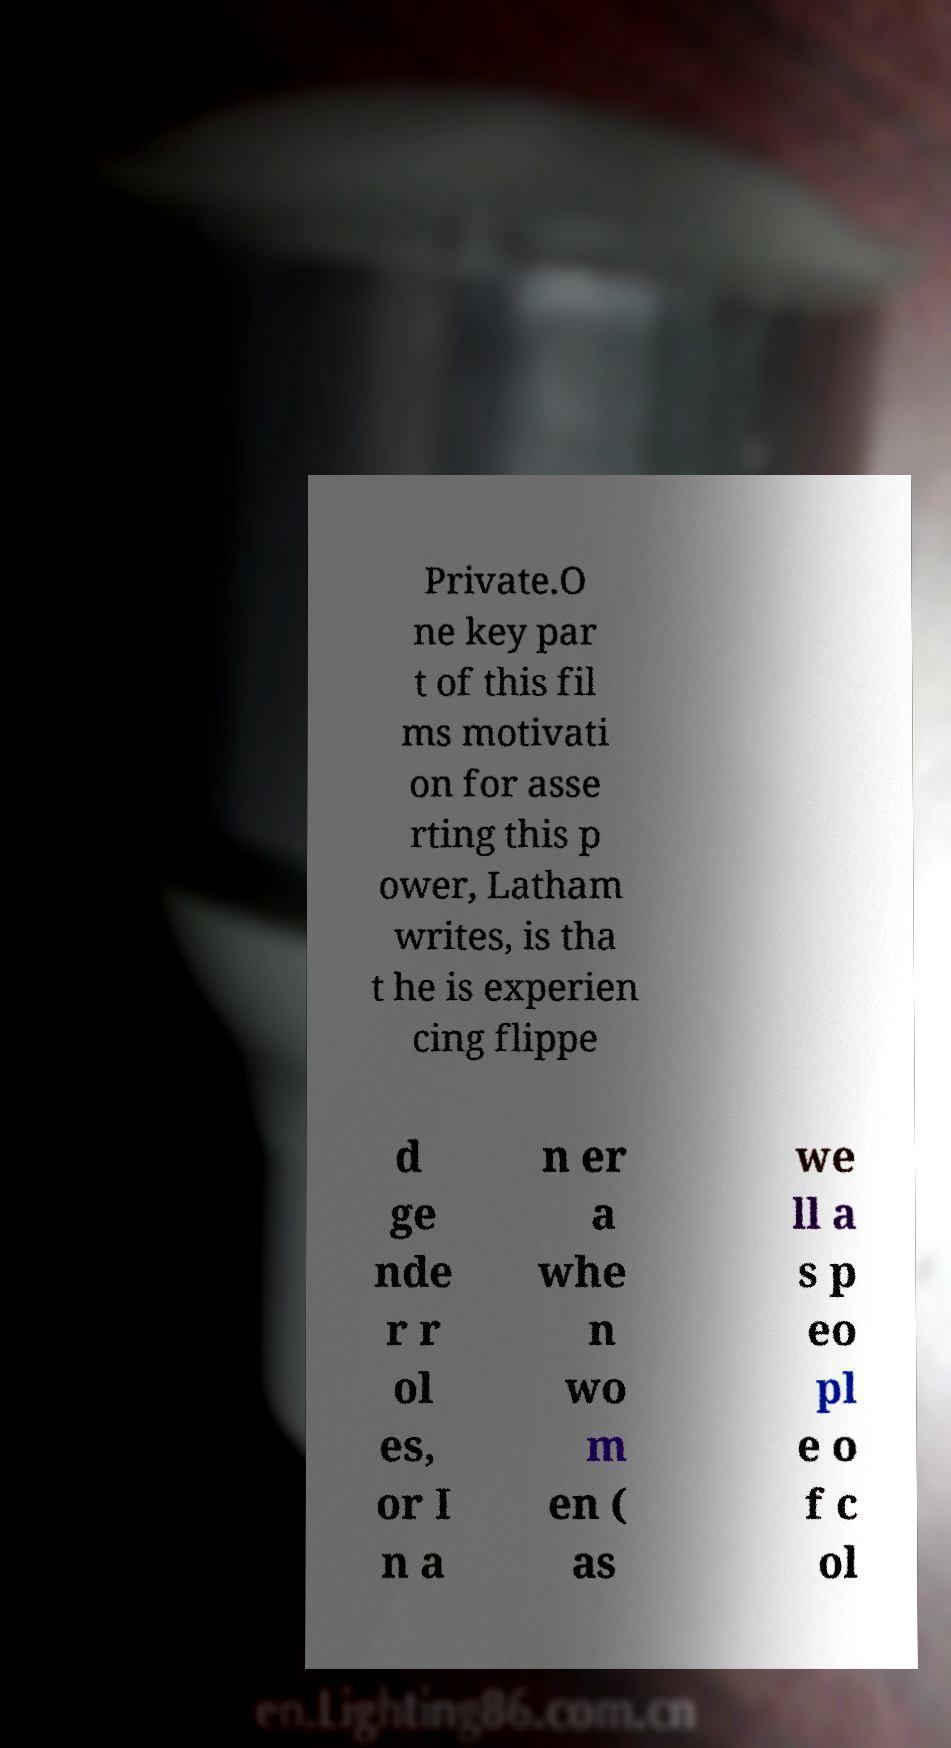For documentation purposes, I need the text within this image transcribed. Could you provide that? Private.O ne key par t of this fil ms motivati on for asse rting this p ower, Latham writes, is tha t he is experien cing flippe d ge nde r r ol es, or I n a n er a whe n wo m en ( as we ll a s p eo pl e o f c ol 